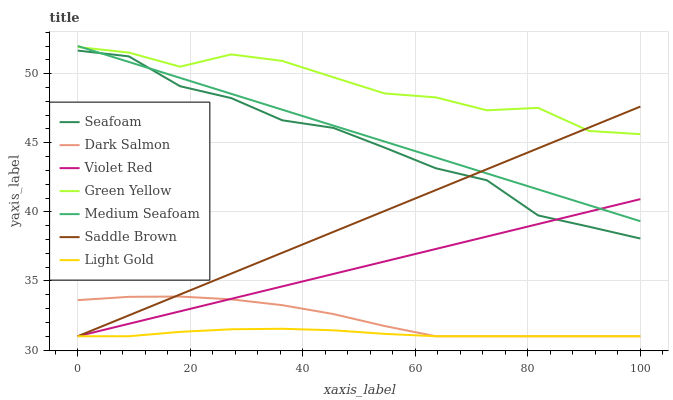Does Light Gold have the minimum area under the curve?
Answer yes or no. Yes. Does Green Yellow have the maximum area under the curve?
Answer yes or no. Yes. Does Seafoam have the minimum area under the curve?
Answer yes or no. No. Does Seafoam have the maximum area under the curve?
Answer yes or no. No. Is Saddle Brown the smoothest?
Answer yes or no. Yes. Is Green Yellow the roughest?
Answer yes or no. Yes. Is Light Gold the smoothest?
Answer yes or no. No. Is Light Gold the roughest?
Answer yes or no. No. Does Violet Red have the lowest value?
Answer yes or no. Yes. Does Seafoam have the lowest value?
Answer yes or no. No. Does Medium Seafoam have the highest value?
Answer yes or no. Yes. Does Seafoam have the highest value?
Answer yes or no. No. Is Violet Red less than Green Yellow?
Answer yes or no. Yes. Is Green Yellow greater than Violet Red?
Answer yes or no. Yes. Does Dark Salmon intersect Violet Red?
Answer yes or no. Yes. Is Dark Salmon less than Violet Red?
Answer yes or no. No. Is Dark Salmon greater than Violet Red?
Answer yes or no. No. Does Violet Red intersect Green Yellow?
Answer yes or no. No. 